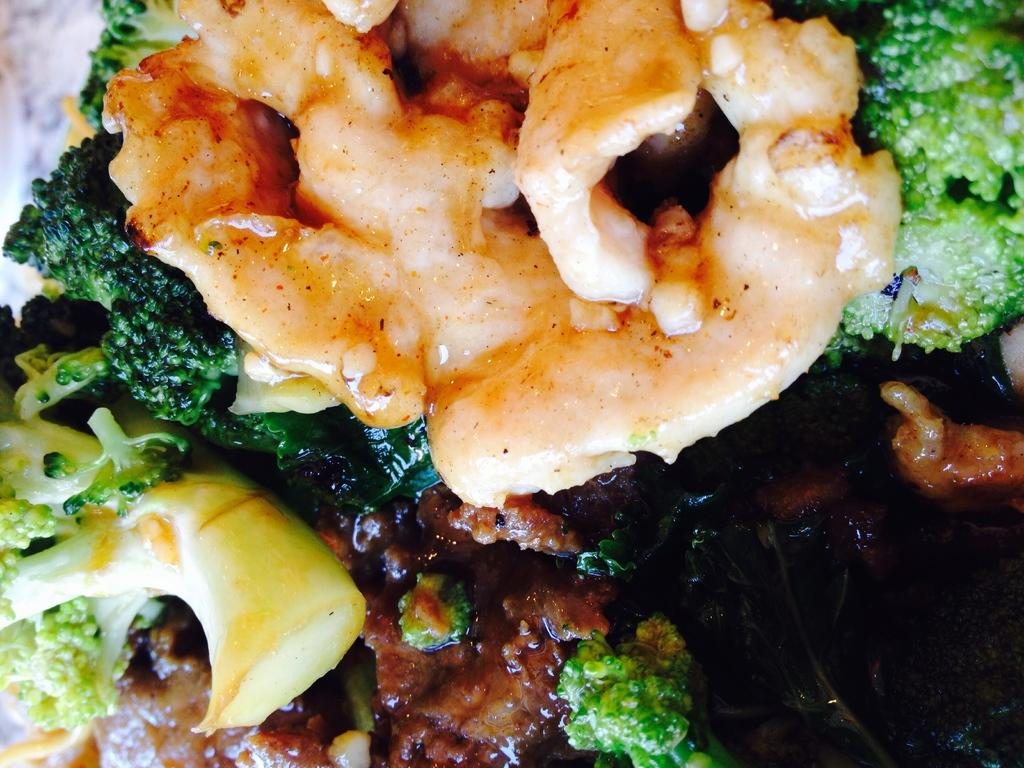What type of items can be seen in the image? The image contains food. Can you describe the color of any vegetables in the image? There are green color vegetables in the image. What is the tendency of the cream to evaporate in the image? There is no cream present in the image, so it is not possible to determine its tendency to evaporate. 